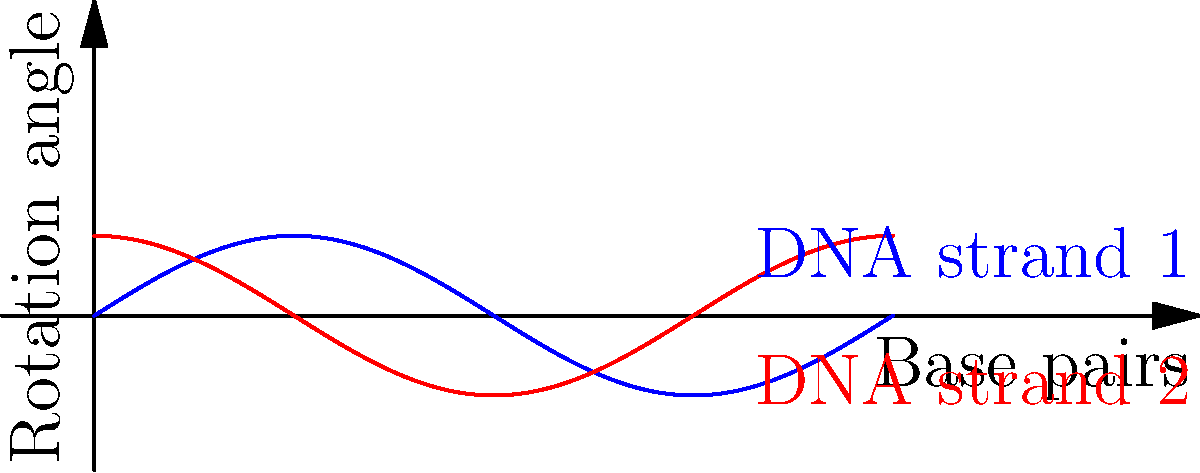Consider the rotational symmetry of a DNA molecule as shown in the graph. The blue curve represents the rotation of one strand, while the red curve represents the rotation of the complementary strand. If the DNA molecule completes a full rotation every 10 base pairs, what is the order of the rotational symmetry group for a 30 base pair segment of this DNA molecule? To solve this problem, let's follow these steps:

1) First, recall that the order of a rotational symmetry group is the number of distinct rotations that bring the object back to its original configuration.

2) From the graph, we can see that one complete rotation occurs every 10 base pairs.

3) We are considering a 30 base pair segment. To find how many complete rotations occur in this segment:

   $\text{Number of rotations} = \frac{\text{Total base pairs}}{\text{Base pairs per rotation}} = \frac{30}{10} = 3$

4) Each of these rotations brings the DNA molecule back to its original configuration.

5) In addition to these rotations, we must consider the identity operation (no rotation), which is always a member of the symmetry group.

6) Therefore, the total number of elements in the rotational symmetry group is:

   $\text{Order of group} = \text{Number of rotations} + \text{Identity} = 3 + 1 = 4$

Thus, the order of the rotational symmetry group for this 30 base pair DNA segment is 4.
Answer: 4 